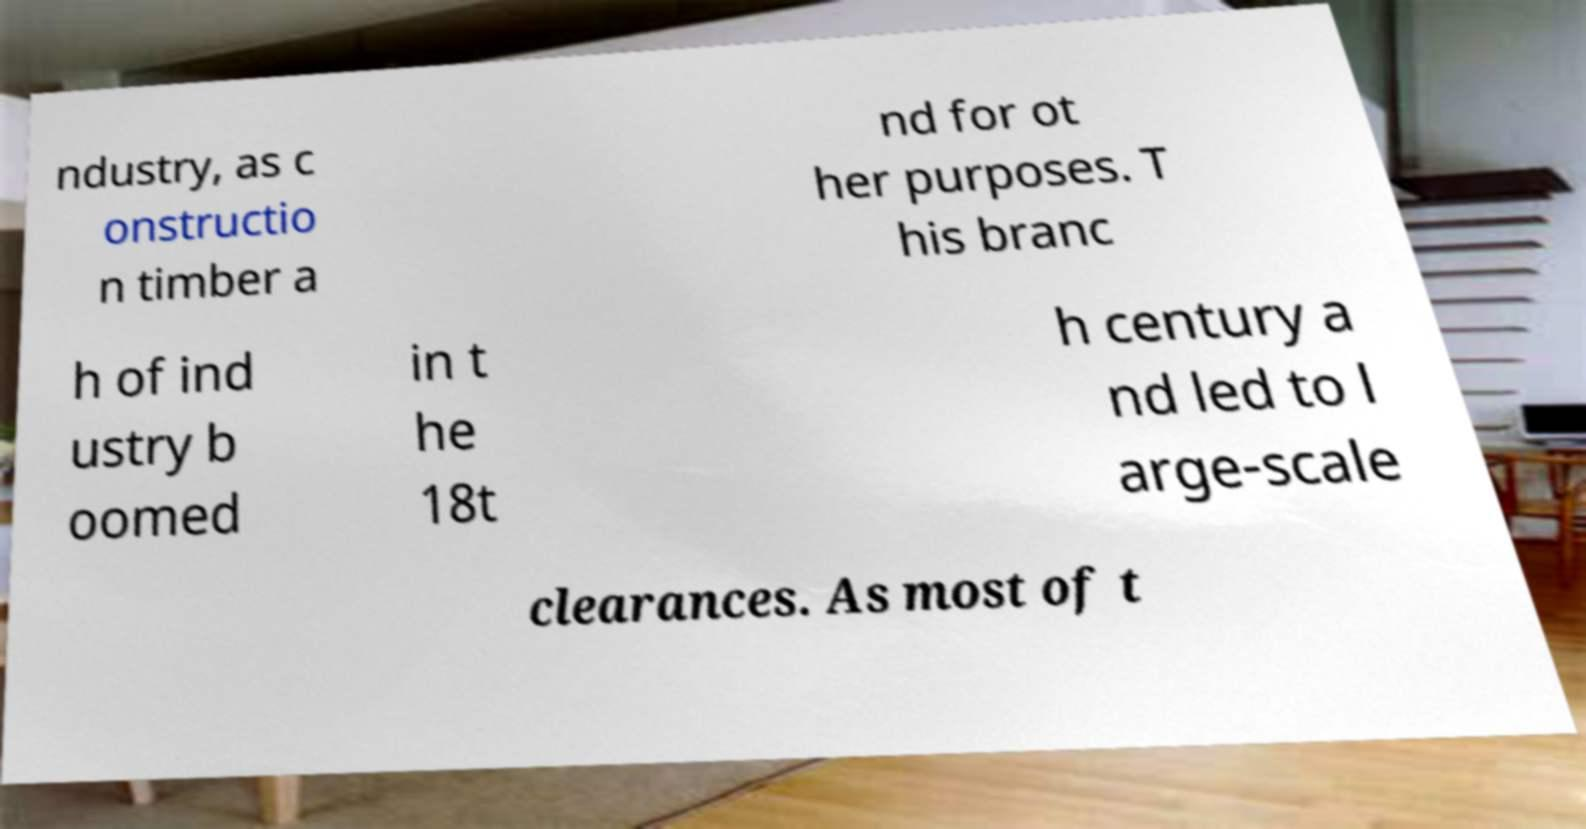Please identify and transcribe the text found in this image. ndustry, as c onstructio n timber a nd for ot her purposes. T his branc h of ind ustry b oomed in t he 18t h century a nd led to l arge-scale clearances. As most of t 